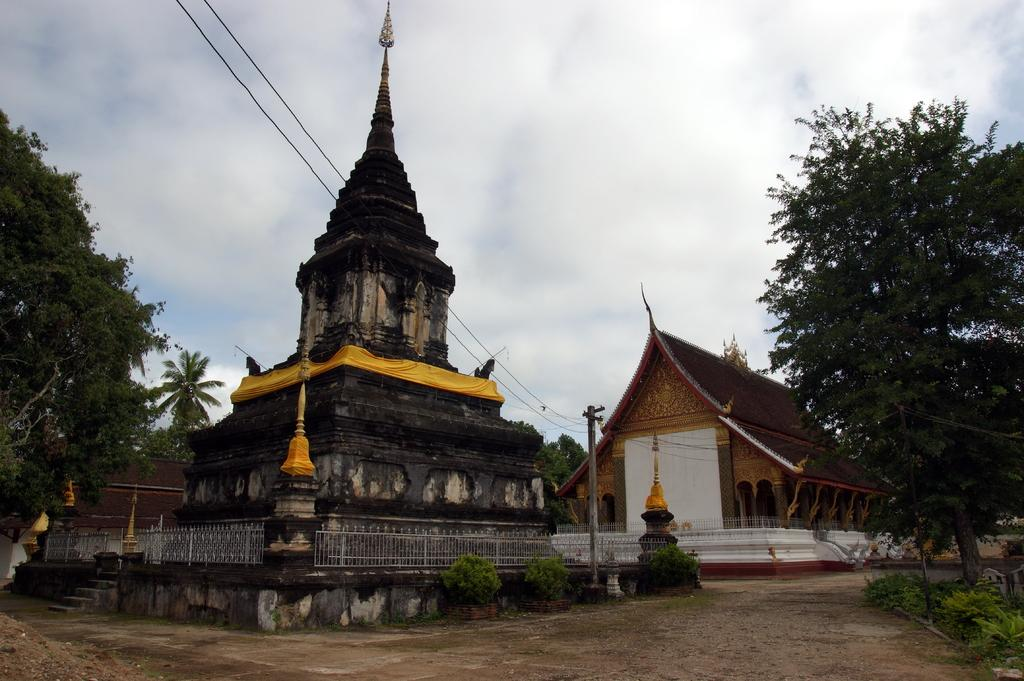What type of structures can be seen in the image? There are architecture buildings in the image. What other objects can be seen in the image? There are current poles, wires, trees, a fence, and steps in the image. What is the condition of the sky in the background? The sky in the background is cloudy. What type of popcorn is being served in the image? There is no popcorn present in the image. How does the stew increase in temperature in the image? There is no stew present in the image, so it cannot be determined how its temperature might change. 